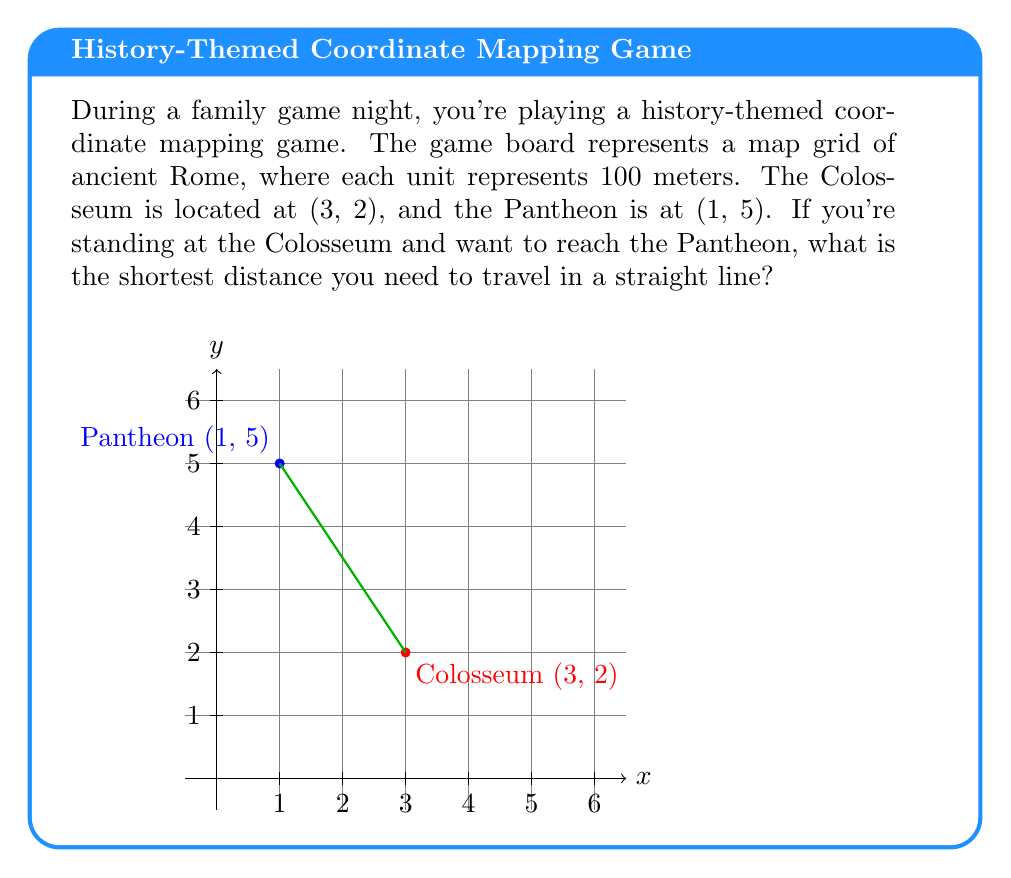Teach me how to tackle this problem. To find the shortest distance between two points on a coordinate plane, we can use the distance formula:

$$d = \sqrt{(x_2-x_1)^2 + (y_2-y_1)^2}$$

Where $(x_1,y_1)$ is the coordinate of the first point and $(x_2,y_2)$ is the coordinate of the second point.

Step 1: Identify the coordinates
- Colosseum: $(x_1,y_1) = (3,2)$
- Pantheon: $(x_2,y_2) = (1,5)$

Step 2: Plug the coordinates into the distance formula
$$d = \sqrt{(1-3)^2 + (5-2)^2}$$

Step 3: Simplify the expressions inside the parentheses
$$d = \sqrt{(-2)^2 + (3)^2}$$

Step 4: Calculate the squares
$$d = \sqrt{4 + 9}$$

Step 5: Add the numbers under the square root
$$d = \sqrt{13}$$

Step 6: Simplify the square root
$$d = \sqrt{13} \approx 3.61$$

Step 7: Interpret the result
Since each unit represents 100 meters, multiply the result by 100:
$$3.61 \times 100 = 361 \text{ meters}$$

Therefore, the shortest distance between the Colosseum and the Pantheon is approximately 361 meters.
Answer: 361 meters 